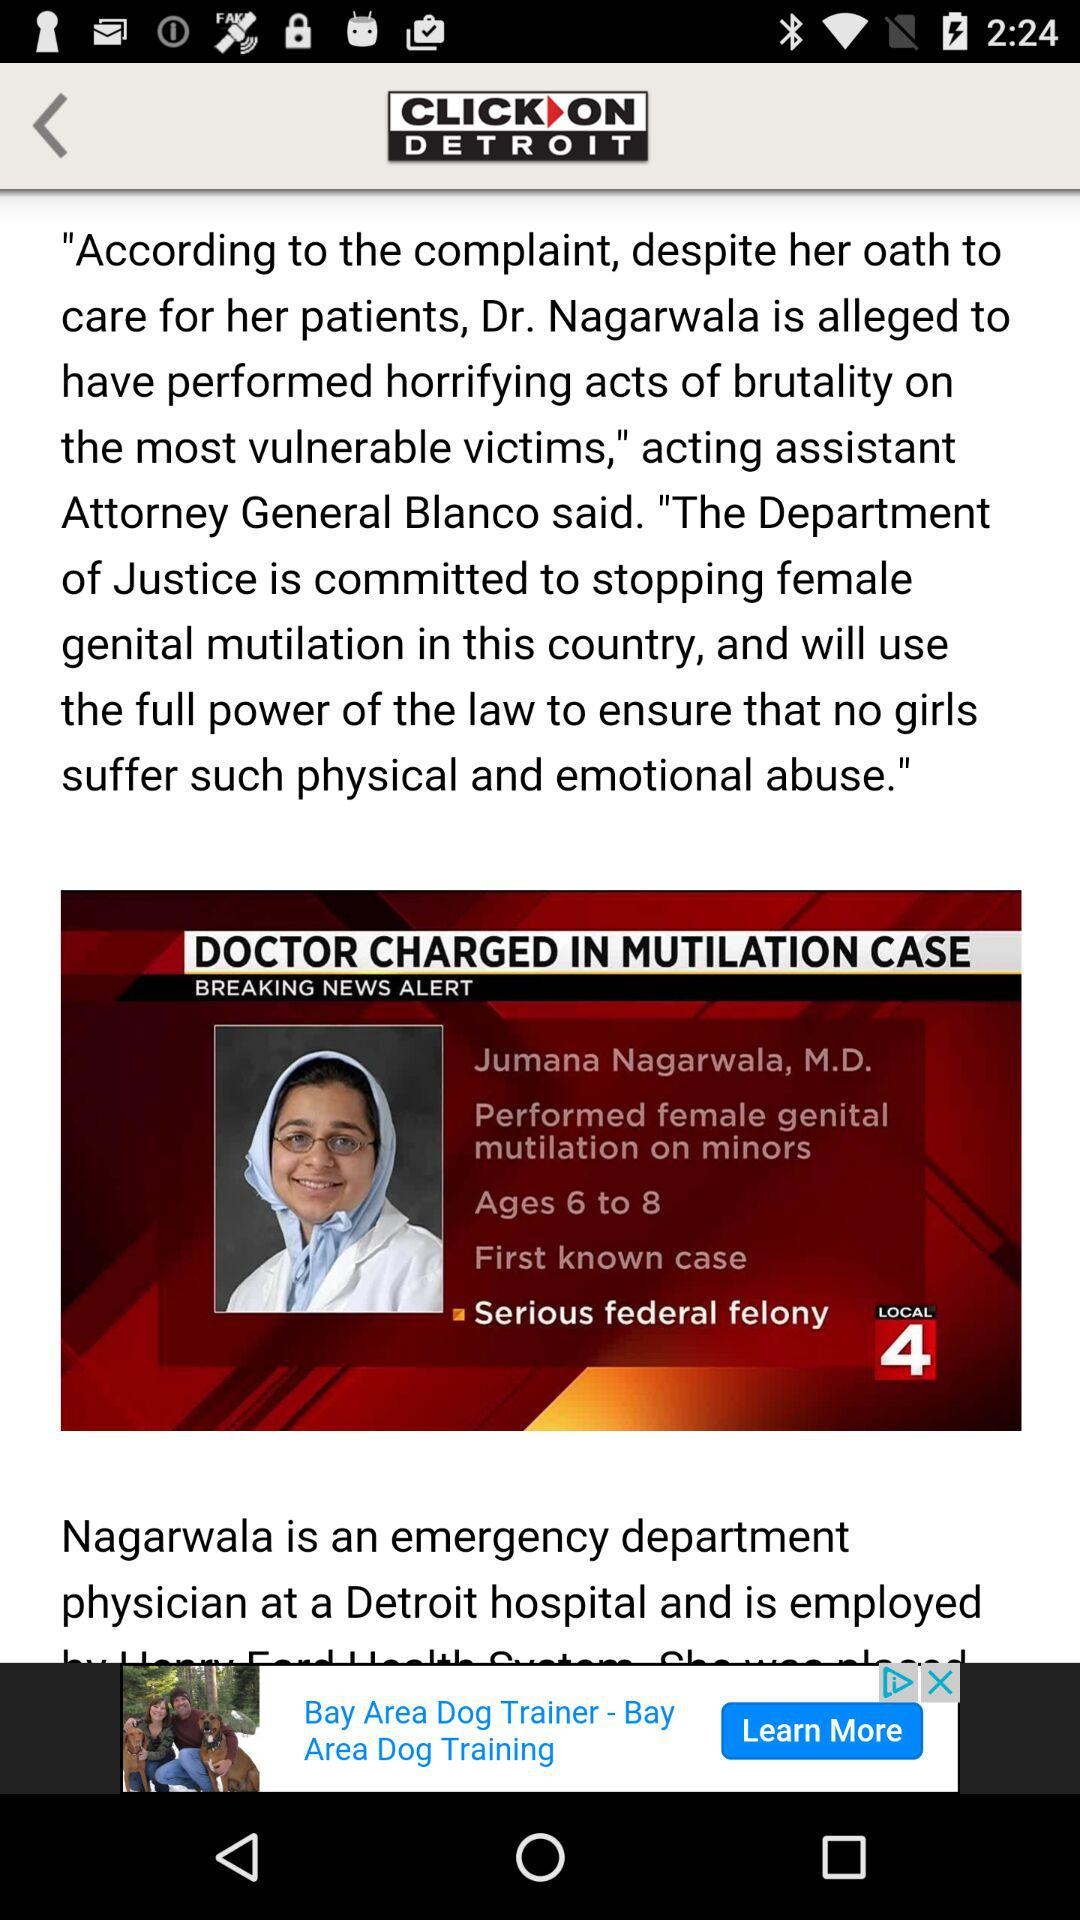What are the ages of the victims? The ages of the victims range from 6 to 8. 